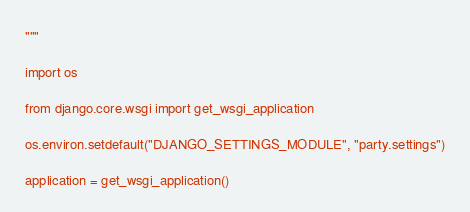<code> <loc_0><loc_0><loc_500><loc_500><_Python_>"""

import os

from django.core.wsgi import get_wsgi_application

os.environ.setdefault("DJANGO_SETTINGS_MODULE", "party.settings")

application = get_wsgi_application()
</code> 